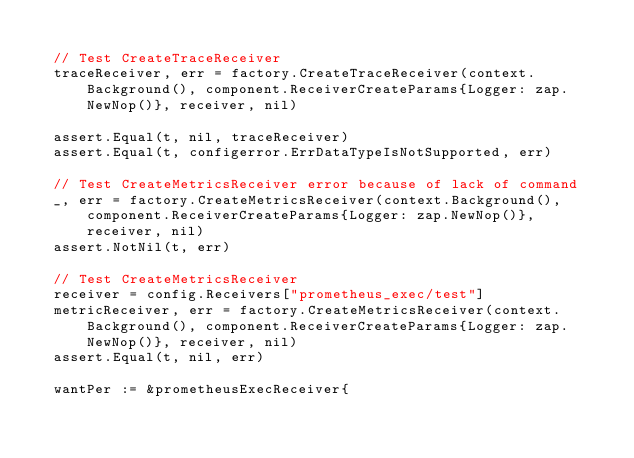<code> <loc_0><loc_0><loc_500><loc_500><_Go_>
	// Test CreateTraceReceiver
	traceReceiver, err = factory.CreateTraceReceiver(context.Background(), component.ReceiverCreateParams{Logger: zap.NewNop()}, receiver, nil)

	assert.Equal(t, nil, traceReceiver)
	assert.Equal(t, configerror.ErrDataTypeIsNotSupported, err)

	// Test CreateMetricsReceiver error because of lack of command
	_, err = factory.CreateMetricsReceiver(context.Background(), component.ReceiverCreateParams{Logger: zap.NewNop()}, receiver, nil)
	assert.NotNil(t, err)

	// Test CreateMetricsReceiver
	receiver = config.Receivers["prometheus_exec/test"]
	metricReceiver, err = factory.CreateMetricsReceiver(context.Background(), component.ReceiverCreateParams{Logger: zap.NewNop()}, receiver, nil)
	assert.Equal(t, nil, err)

	wantPer := &prometheusExecReceiver{</code> 